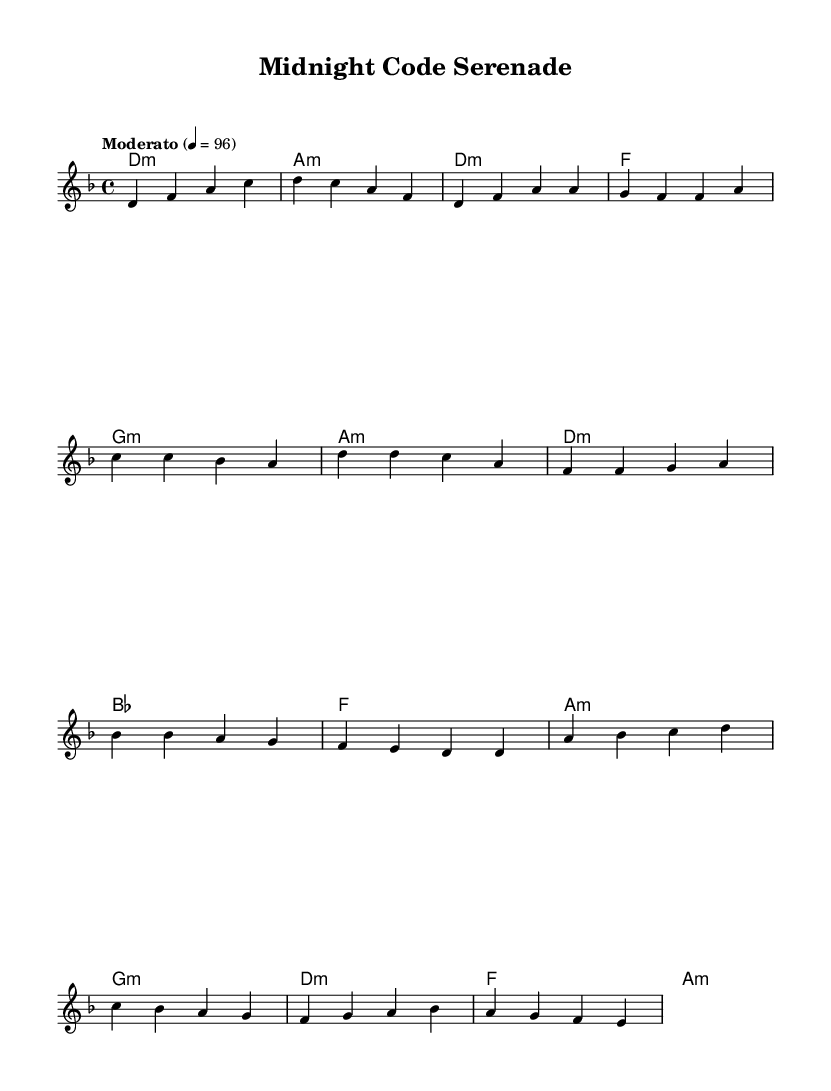What is the key signature of this music? The key signature is D minor, which has one flat (B flat). By looking at the key signature section in the music, the presence of the flat indicates D minor.
Answer: D minor What is the time signature of the piece? The time signature is 4/4, which is shown at the beginning of the score next to the key signature. This means there are four beats in each measure.
Answer: 4/4 What is the tempo marking of the piece? The tempo marking is "Moderato," and the metronome marking is 4 equals 96. This indicates a moderate pace at which the piece should be played.
Answer: Moderato How many measures are in the verse? The verse consists of four measures, which can be counted within the music from the beginning of the verse section to the end. Each measure is separated by vertical lines in the score.
Answer: Four measures What is the chord for the first measure of the chorus? The first measure of the chorus has the chord D minor indicated above. This is visible from the chord names at the top of the staff, under which the melody is played.
Answer: D minor What is the last chord in the bridge section? The last chord in the bridge section is A minor. The chord sequence can be followed from the harmonies provided in that segment of the music, and the final measure shows the A minor chord.
Answer: A minor 